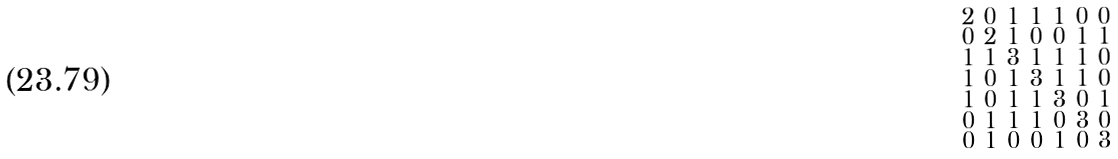Convert formula to latex. <formula><loc_0><loc_0><loc_500><loc_500>\begin{smallmatrix} 2 & 0 & 1 & 1 & 1 & 0 & 0 \\ 0 & 2 & 1 & 0 & 0 & 1 & 1 \\ 1 & 1 & 3 & 1 & 1 & 1 & 0 \\ 1 & 0 & 1 & 3 & 1 & 1 & 0 \\ 1 & 0 & 1 & 1 & 3 & 0 & 1 \\ 0 & 1 & 1 & 1 & 0 & 3 & 0 \\ 0 & 1 & 0 & 0 & 1 & 0 & 3 \end{smallmatrix}</formula> 